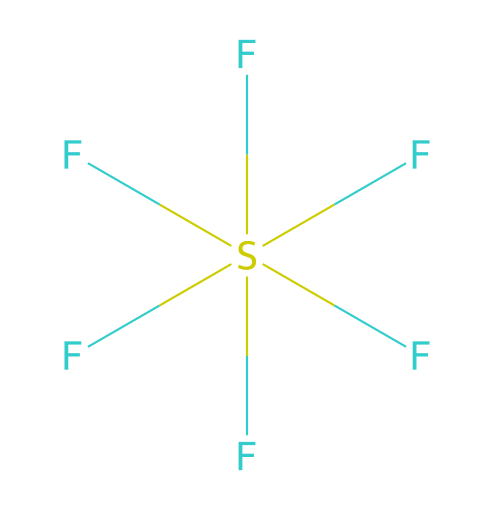What is the name of this compound? The SMILES representation shows sulfur surrounded by six fluorine atoms, which identifies this as sulfur hexafluoride.
Answer: sulfur hexafluoride How many fluorine atoms are in this molecule? By inspecting the SMILES representation, there are six fluorine atoms denoted by the six 'F' symbols, each bonded to the sulfur atom.
Answer: six What type of hybridization does sulfur exhibit in this compound? Sulfur in sulfur hexafluoride is sp³d² hybridized, which is a consequence of having six bonding pairs (from six F atoms) and no lone pairs on sulfur.
Answer: sp³d² Why is sulfur able to form hypervalent compounds like this one? Sulfur can expand its valence shell beyond the octet rule due to its ability to utilize d orbitals, allowing it to bond with more than four atoms, as seen here with six fluorines.
Answer: d orbitals What property makes sulfur hexafluoride useful in electrical insulation? Its high electronegativity and stable bonding due to hypervalent character contribute to its excellent dielectric strength, making it useful in high-voltage applications.
Answer: dielectric strength How many total bonds are present in sulfur hexafluoride? Each fluorine atom forms a single bond with sulfur, resulting in a total of six F-S bonds in the molecule.
Answer: six Can sulfur hexafluoride be classified as a polar or nonpolar molecule? Due to the symmetrical arrangement of the six identical fluorine atoms around sulfur, the molecule is nonpolar, even though S-F bonds are polar.
Answer: nonpolar 